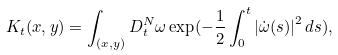<formula> <loc_0><loc_0><loc_500><loc_500>K _ { t } ( x , y ) = \int _ { ( x , y ) } D _ { t } ^ { N } \omega \exp ( - \frac { 1 } { 2 } \int _ { 0 } ^ { t } \left | \dot { \omega } ( s ) \right | ^ { 2 } d s ) ,</formula> 